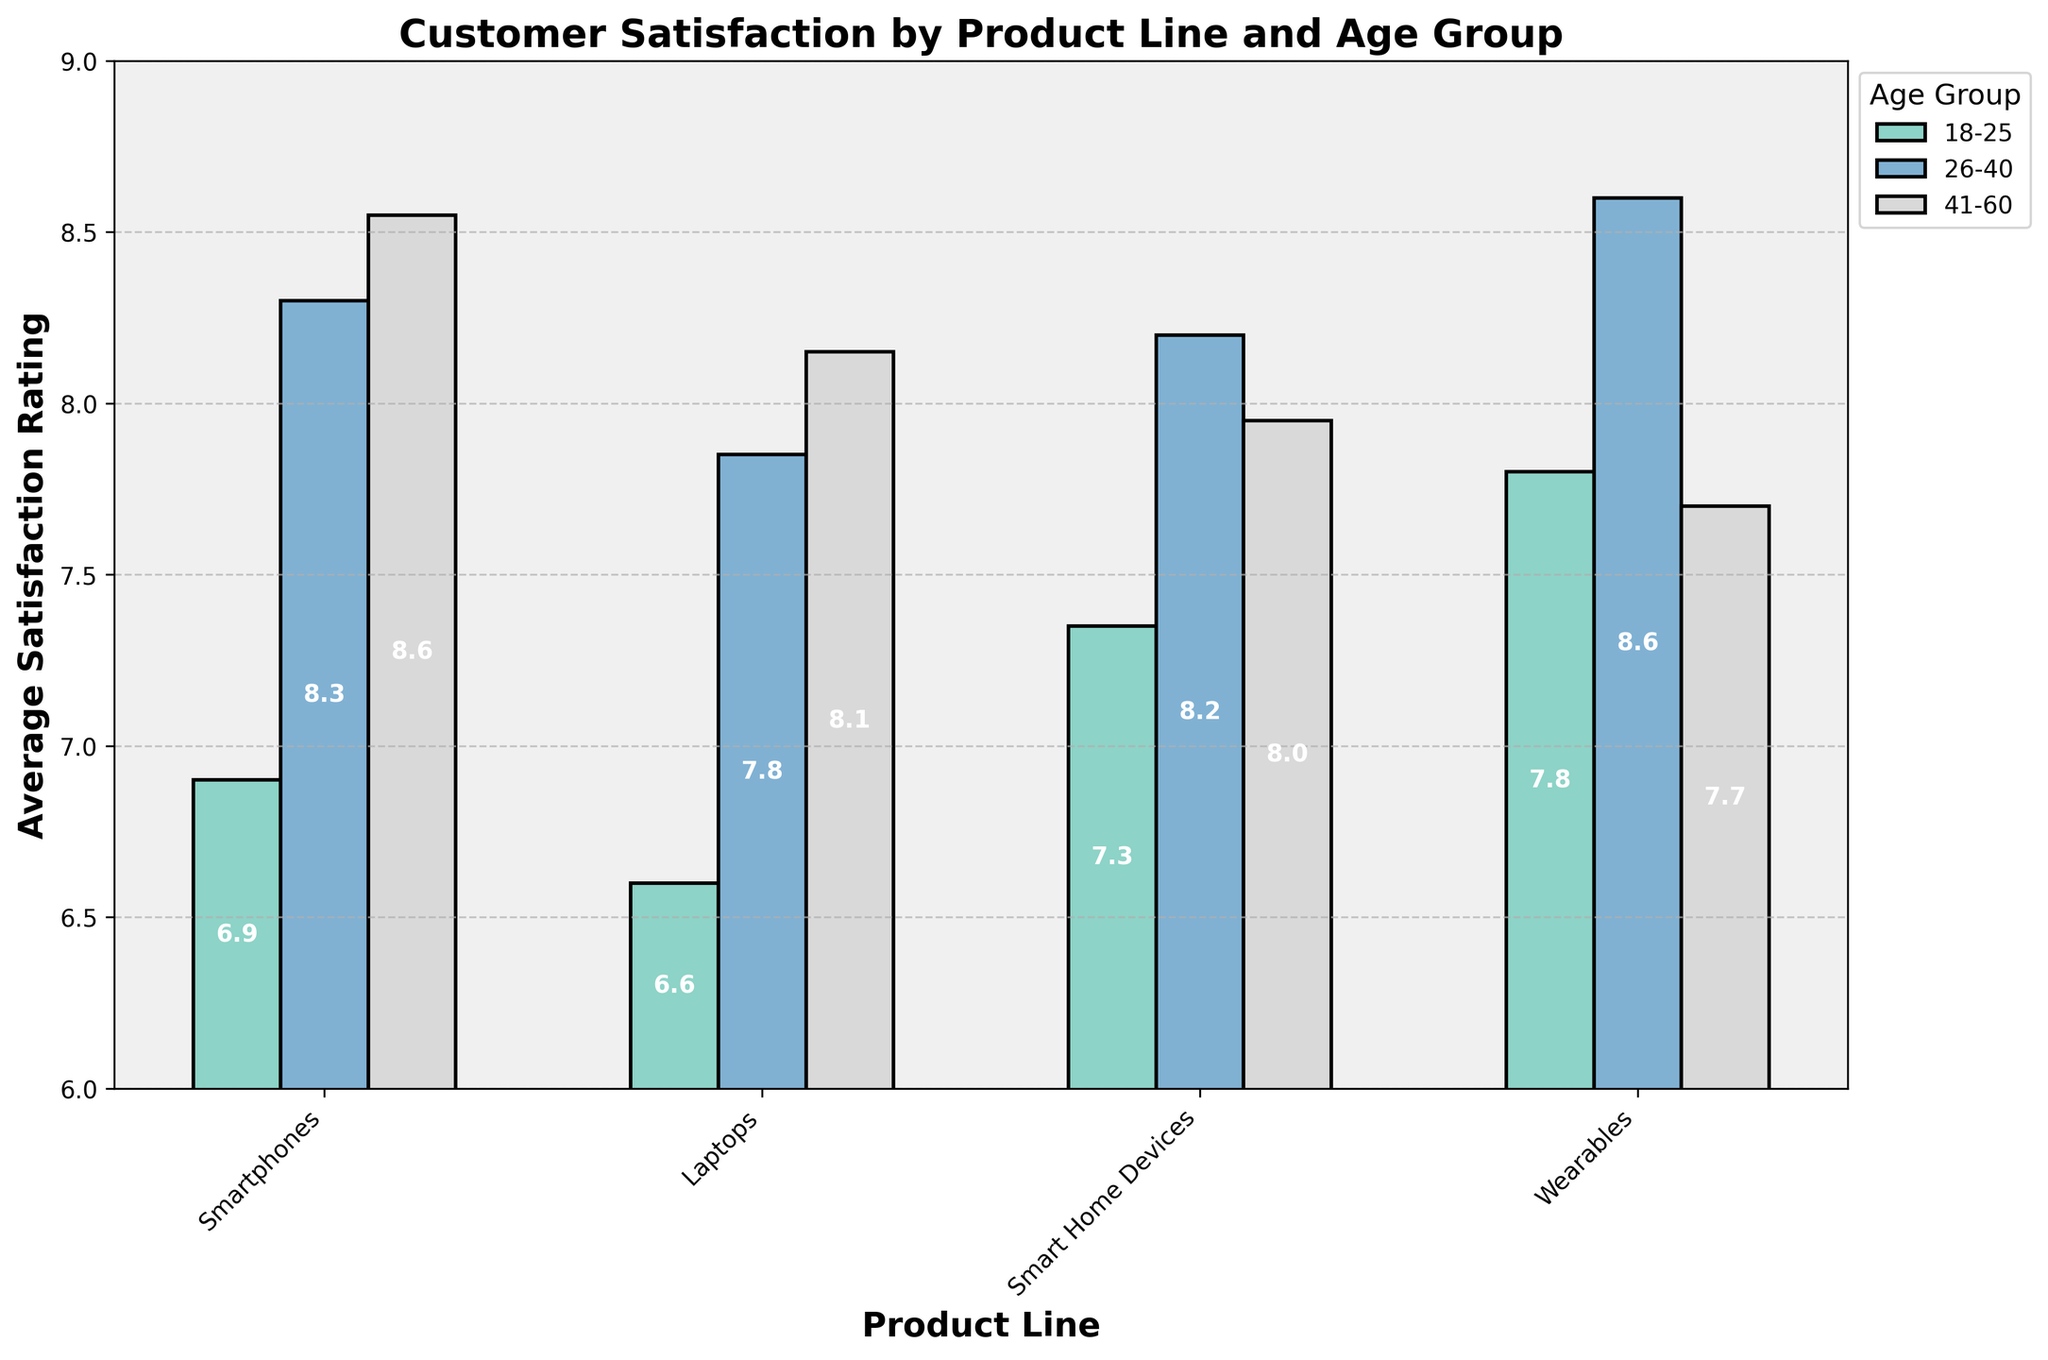Which product line has the highest overall satisfaction rating for the 26-40 age group? Look at the bars labeled for the 26-40 age group across all product lines and identify the tallest one. This corresponds to the highest satisfaction rating.
Answer: Wearables Which product line has the lowest satisfaction rating among the 18-25 age group? Compare the height of the bars for the 18-25 age group across all product lines and identify the shortest one. This corresponds to the lowest satisfaction rating.
Answer: Smart Home Devices What is the difference between the highest and lowest satisfaction ratings within the Smart Home Devices product line? Identify the highest and lowest bars within the Smart Home Devices group and calculate the difference between their values.
Answer: 1.7 Compare the average satisfaction rating for Laptops and Smartphones in the 26-40 age group. Which one is higher? Look at the bars for Laptops and Smartphones in the 26-40 age group. The one with the higher average satisfaction rating will have a taller bar.
Answer: Laptops For the 41-60 age group, which product line has the closest satisfaction rating between males and females? Compare the heights of the bars for males and females in the 41-60 age group across all product lines and identify the pair that has the least difference in height.
Answer: Smart Home Devices Which product line shows a noticeable increase in satisfaction rating from the 18-25 age group to the 26-40 age group? Observe the bars for the 18-25 and 26-40 age groups for each product line. Identify the product line where the bar height significantly increases.
Answer: Laptops Which gender has higher satisfaction ratings for Wearables in the 26-40 age group? Look at the bars for the 26-40 age group under the Wearables product line and compare the heights for males and females.
Answer: Female Which age group has the most consistent satisfaction ratings across all product lines? Compare the variation in bar heights across different product lines for each age group. The age group with the least variation (most similar heights) is the most consistent.
Answer: 26-40 Which product line shows the highest satisfaction ratings for customers with a high income level, specifically in the 41-60 age group? Examine the heights of the bars for each product line in the 41-60 age group and focus on customers with a high income level. Identify the tallest bar in this subset.
Answer: Laptops What is the average satisfaction rating across all age groups for Smartphones? Add up the satisfaction ratings for all age groups under the Smartphones product line and divide by the number of age groups.
Answer: 7.8 